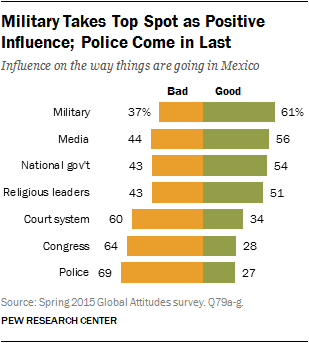Indicate a few pertinent items in this graphic. The military and the police differ in their positive influence on society. The military serves to protect the nation and its citizens through the use of force, while the police are responsible for maintaining order and enforcing laws within a given jurisdiction. The military's positive influence often involves ensuring national security and promoting peacekeeping efforts, while the police's positive influence is primarily focused on maintaining public safety and protecting the rights and welfare of citizens. 